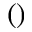<formula> <loc_0><loc_0><loc_500><loc_500>( )</formula> 